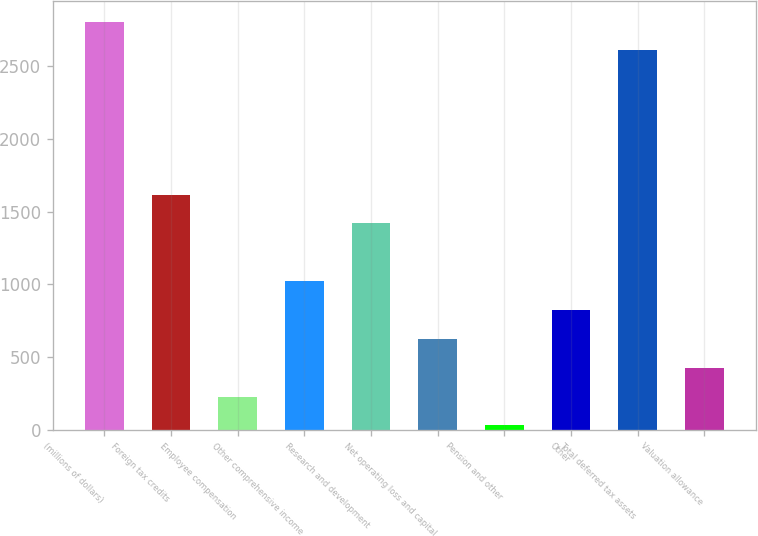Convert chart. <chart><loc_0><loc_0><loc_500><loc_500><bar_chart><fcel>(millions of dollars)<fcel>Foreign tax credits<fcel>Employee compensation<fcel>Other comprehensive income<fcel>Research and development<fcel>Net operating loss and capital<fcel>Pension and other<fcel>Other<fcel>Total deferred tax assets<fcel>Valuation allowance<nl><fcel>2807.84<fcel>1617.08<fcel>227.86<fcel>1021.7<fcel>1418.62<fcel>624.78<fcel>29.4<fcel>823.24<fcel>2609.38<fcel>426.32<nl></chart> 